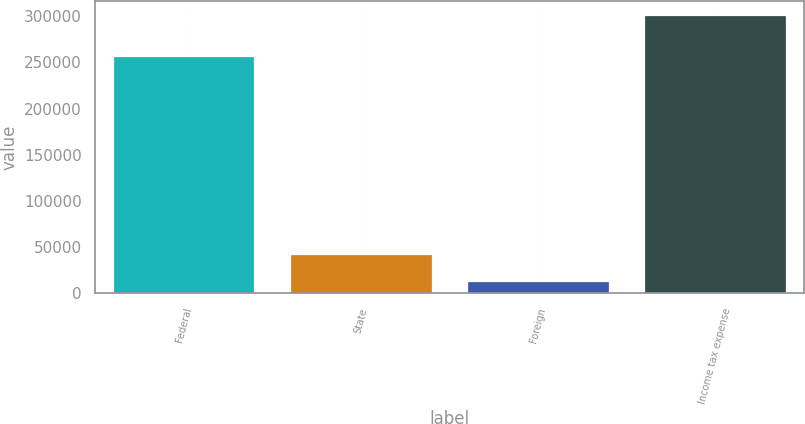Convert chart to OTSL. <chart><loc_0><loc_0><loc_500><loc_500><bar_chart><fcel>Federal<fcel>State<fcel>Foreign<fcel>Income tax expense<nl><fcel>256748<fcel>42481.5<fcel>13677<fcel>301722<nl></chart> 